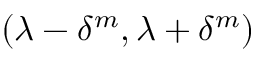Convert formula to latex. <formula><loc_0><loc_0><loc_500><loc_500>( \lambda - \delta ^ { m } , \lambda + \delta ^ { m } )</formula> 